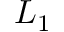Convert formula to latex. <formula><loc_0><loc_0><loc_500><loc_500>L _ { 1 }</formula> 